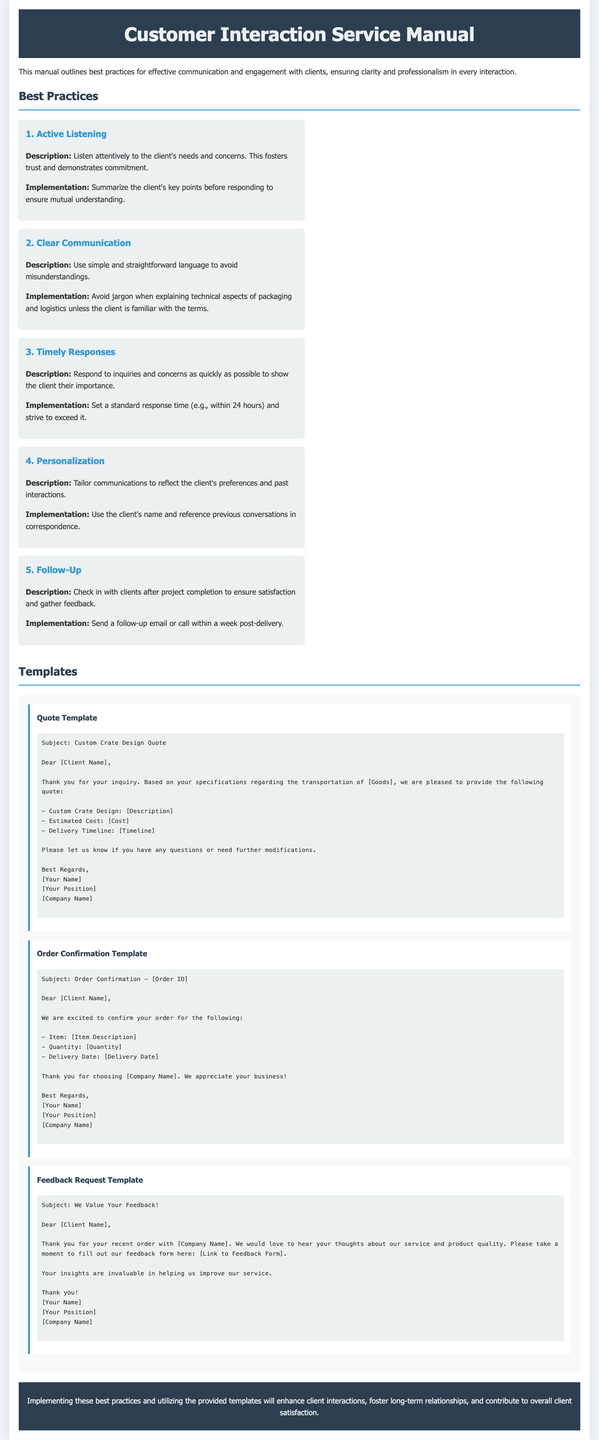What is the title of the document? The title is displayed prominently in the header section of the document.
Answer: Customer Interaction Service Manual How many best practices are listed in the document? The number of best practices is summarized in the document section that lists them.
Answer: Five What should be included in the quote template? The quote template outlines the necessary components for pricing and details regarding custom crate design.
Answer: Custom Crate Design, Estimated Cost, Delivery Timeline What is the subject line for the Feedback Request Template? The subject line is clearly stated at the beginning of that template section.
Answer: We Value Your Feedback! What is the recommended response time for client inquiries? The document specifies a standard response time expectation for engaging with clients.
Answer: Within 24 hours Which best practice focuses on client satisfaction after project completion? The specific best practice related to post-project client engagement is mentioned.
Answer: Follow-Up What color is used for headers in the document? The color scheme for headings can be found in the style definitions within the document.
Answer: Dark blue What is the purpose of the Customer Interaction Service Manual? The main goal of the document is outlined in the introductory paragraph.
Answer: Effective communication and engagement with clients What type of template is used for confirming orders? The document classifies the type of communication related to order confirmations.
Answer: Order Confirmation Template 